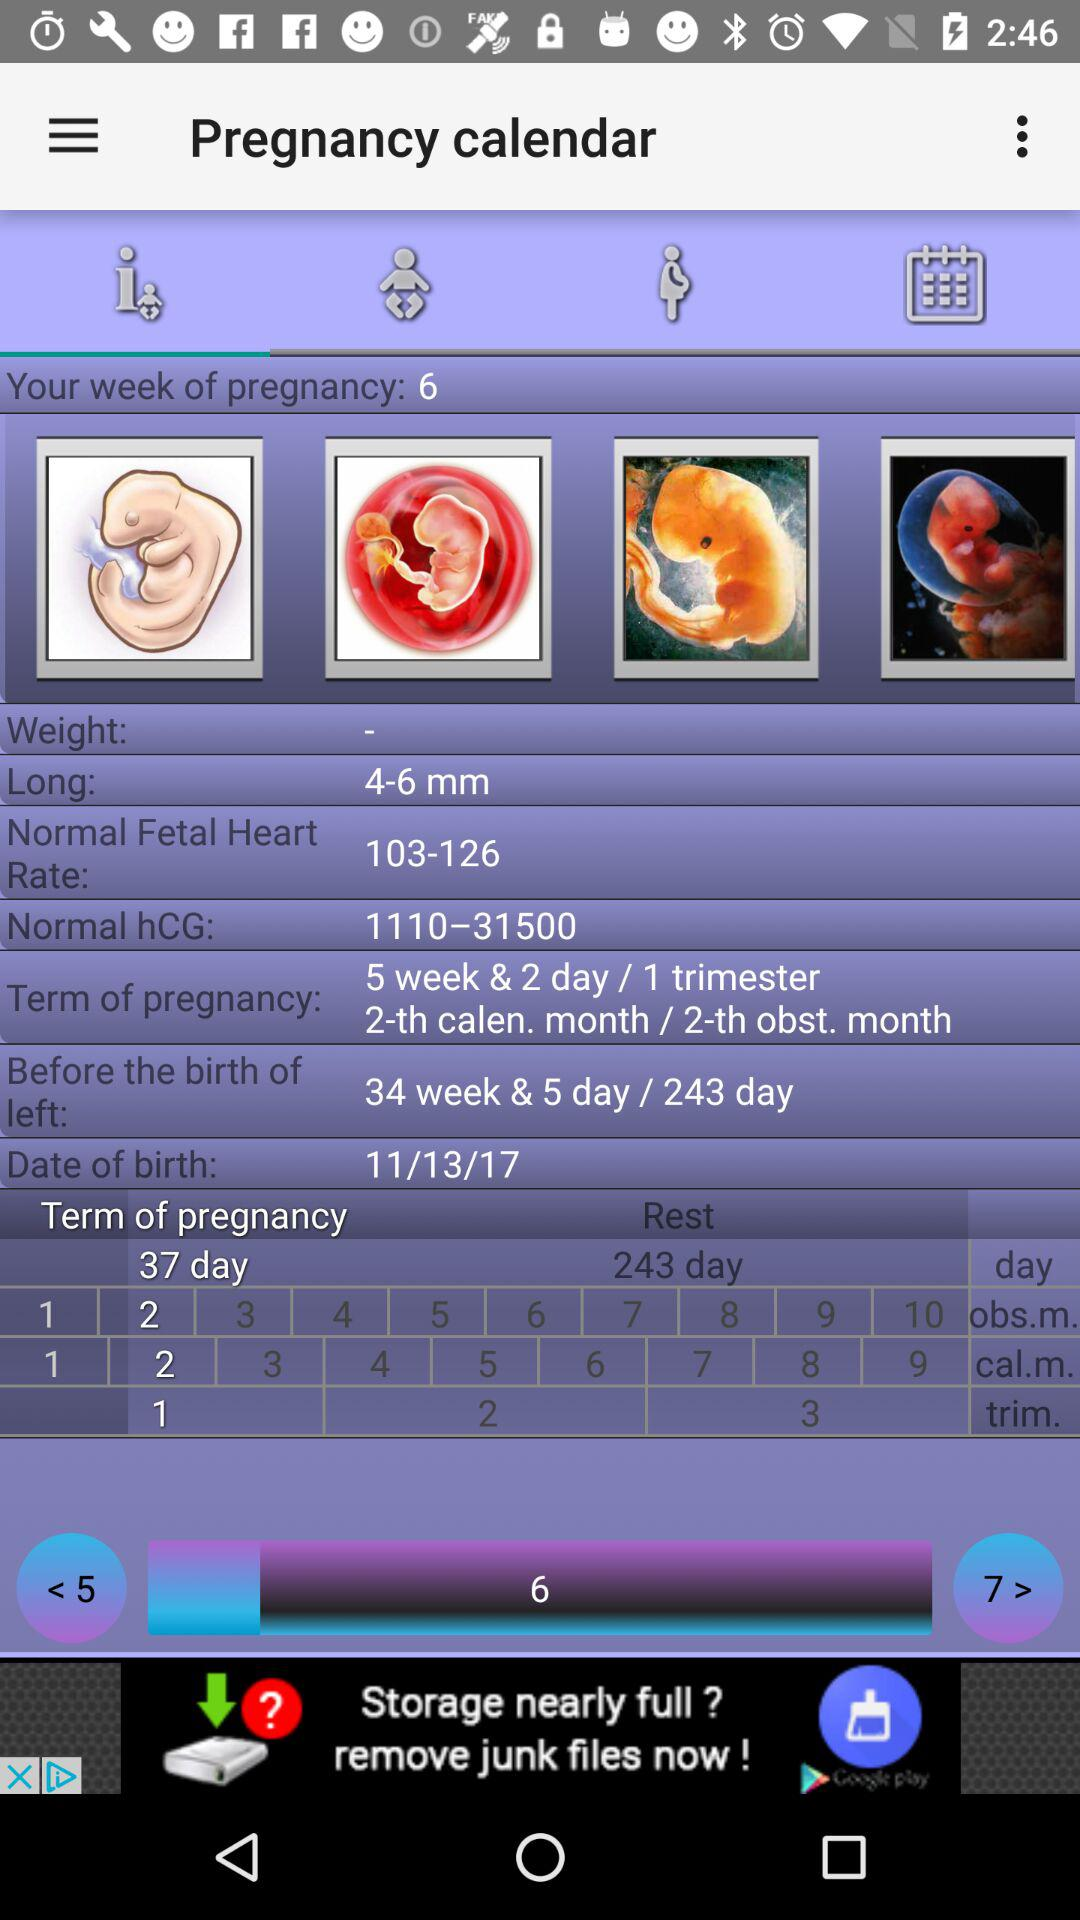What is showing "Normal hCG"? "Normal hCG" is showing 1110-31500. 